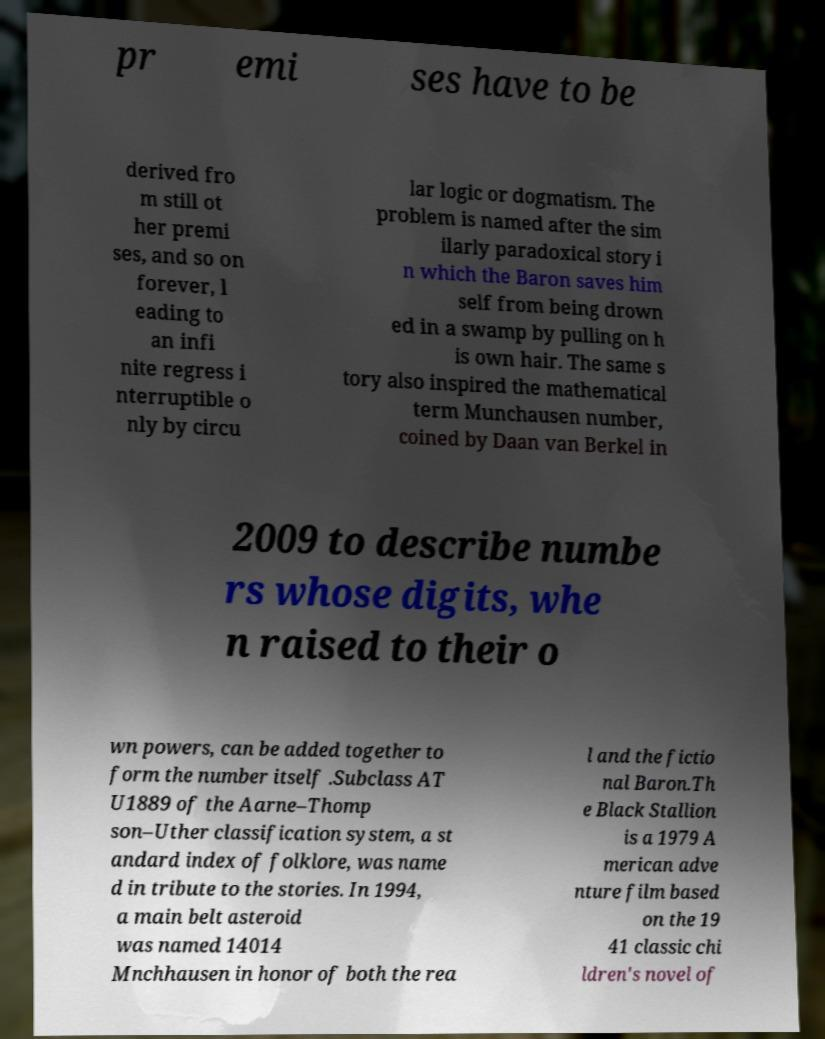Can you read and provide the text displayed in the image?This photo seems to have some interesting text. Can you extract and type it out for me? pr emi ses have to be derived fro m still ot her premi ses, and so on forever, l eading to an infi nite regress i nterruptible o nly by circu lar logic or dogmatism. The problem is named after the sim ilarly paradoxical story i n which the Baron saves him self from being drown ed in a swamp by pulling on h is own hair. The same s tory also inspired the mathematical term Munchausen number, coined by Daan van Berkel in 2009 to describe numbe rs whose digits, whe n raised to their o wn powers, can be added together to form the number itself .Subclass AT U1889 of the Aarne–Thomp son–Uther classification system, a st andard index of folklore, was name d in tribute to the stories. In 1994, a main belt asteroid was named 14014 Mnchhausen in honor of both the rea l and the fictio nal Baron.Th e Black Stallion is a 1979 A merican adve nture film based on the 19 41 classic chi ldren's novel of 